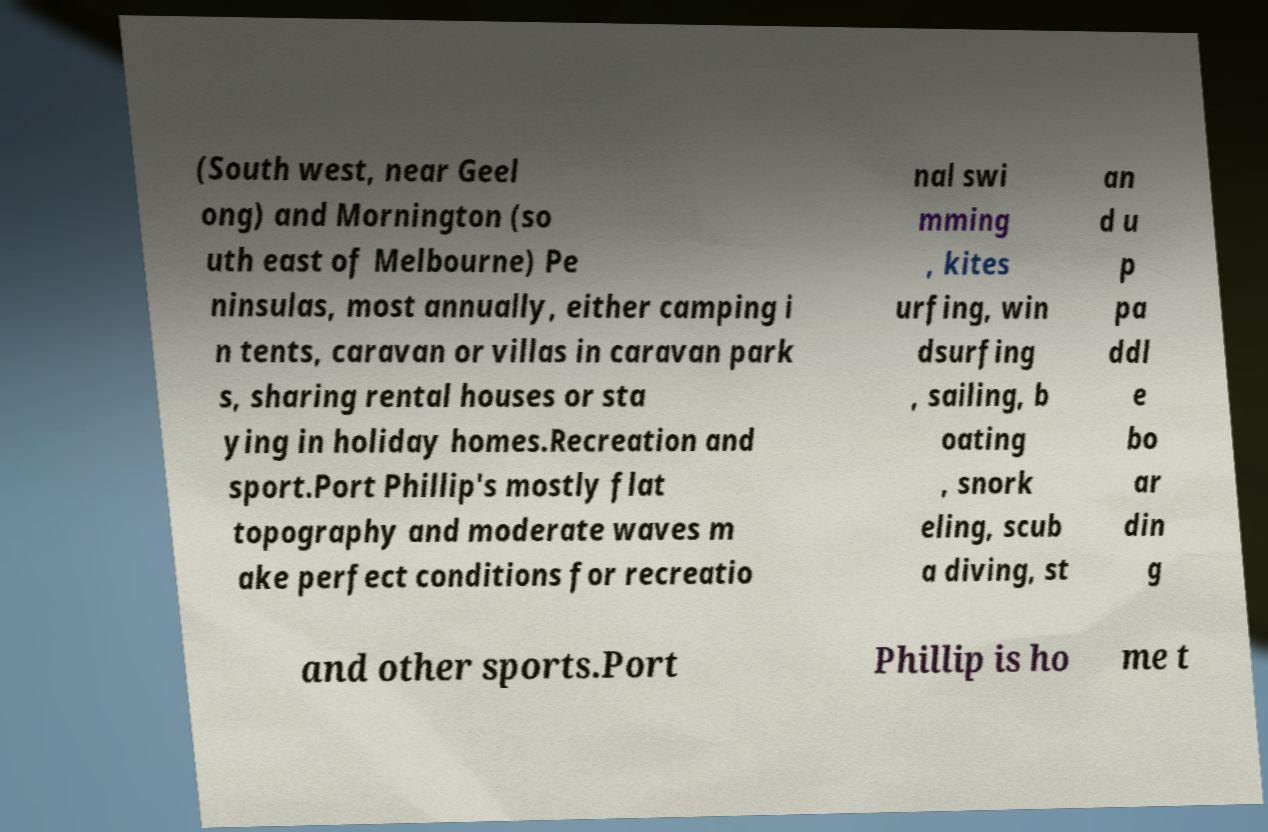Could you assist in decoding the text presented in this image and type it out clearly? (South west, near Geel ong) and Mornington (so uth east of Melbourne) Pe ninsulas, most annually, either camping i n tents, caravan or villas in caravan park s, sharing rental houses or sta ying in holiday homes.Recreation and sport.Port Phillip's mostly flat topography and moderate waves m ake perfect conditions for recreatio nal swi mming , kites urfing, win dsurfing , sailing, b oating , snork eling, scub a diving, st an d u p pa ddl e bo ar din g and other sports.Port Phillip is ho me t 